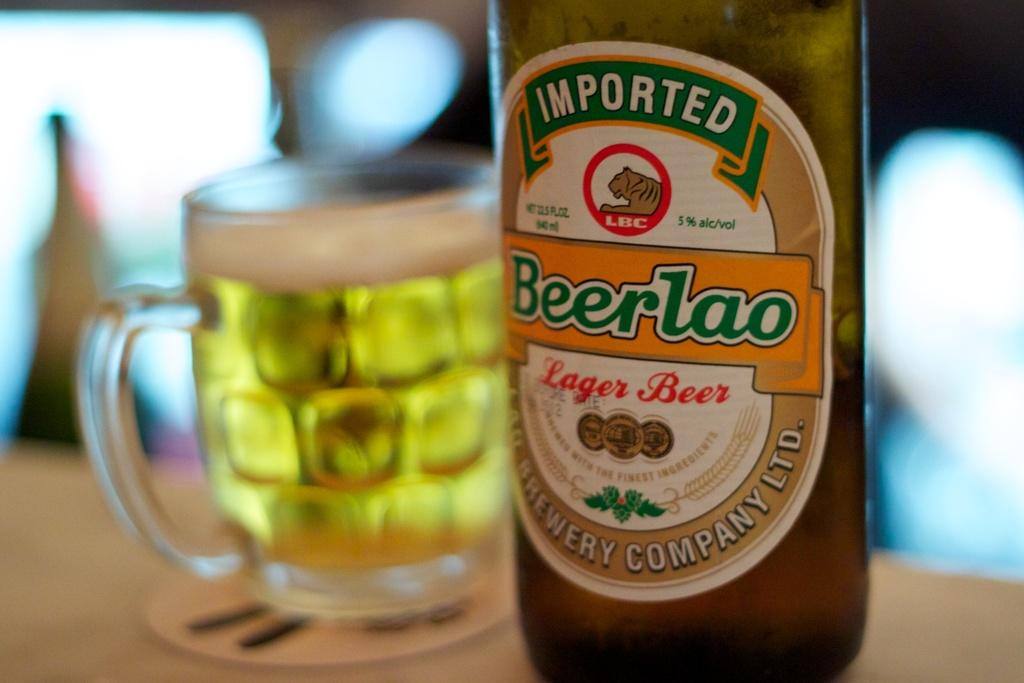<image>
Provide a brief description of the given image. a close up of a glass and bottle of Beerlao 